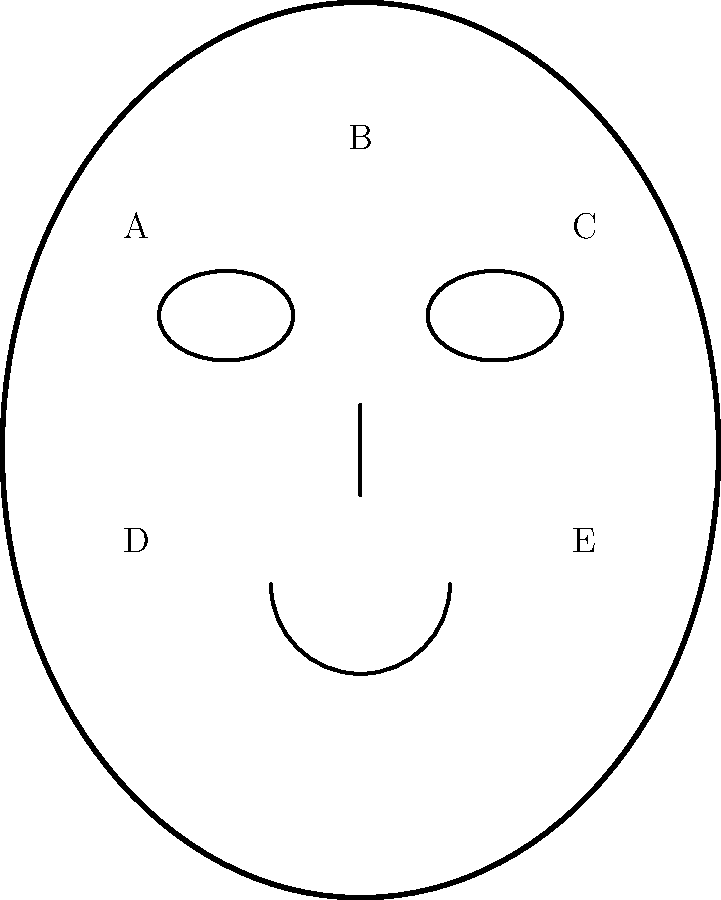Match the following skincare products to the most appropriate face zones labeled in the diagram:

1. Hydrating serum
2. Oil-control moisturizer
3. Eye cream
4. Gentle exfoliant
5. Lip balm To match skincare products to face zones, we need to consider the specific needs of each area:

1. Zone A and C (Cheeks): These areas are typically drier and more sensitive. A hydrating serum would be most beneficial here to provide moisture and nourishment.

2. Zone B (T-zone: Forehead, nose): This area tends to be oilier. An oil-control moisturizer would help manage excess sebum production while still providing necessary hydration.

3. Zones around the eyes (near A and C): The skin around the eyes is delicate and prone to fine lines. Eye cream is specifically formulated for this sensitive area.

4. Forehead and nose (part of Zone B): These areas can benefit from gentle exfoliation to remove dead skin cells and unclog pores. However, exfoliants should be used cautiously and not too frequently.

5. Zone around the mouth (between D and E): The lips and surrounding area require extra moisture. A lip balm helps prevent dryness and chapping.

Therefore, the best matches are:
A and C: Hydrating serum
B: Oil-control moisturizer and gentle exfoliant
Near A and C (eye area): Eye cream
Between D and E (lip area): Lip balm
Answer: A,C: 1; B: 2,4; Near A,C: 3; Between D,E: 5 